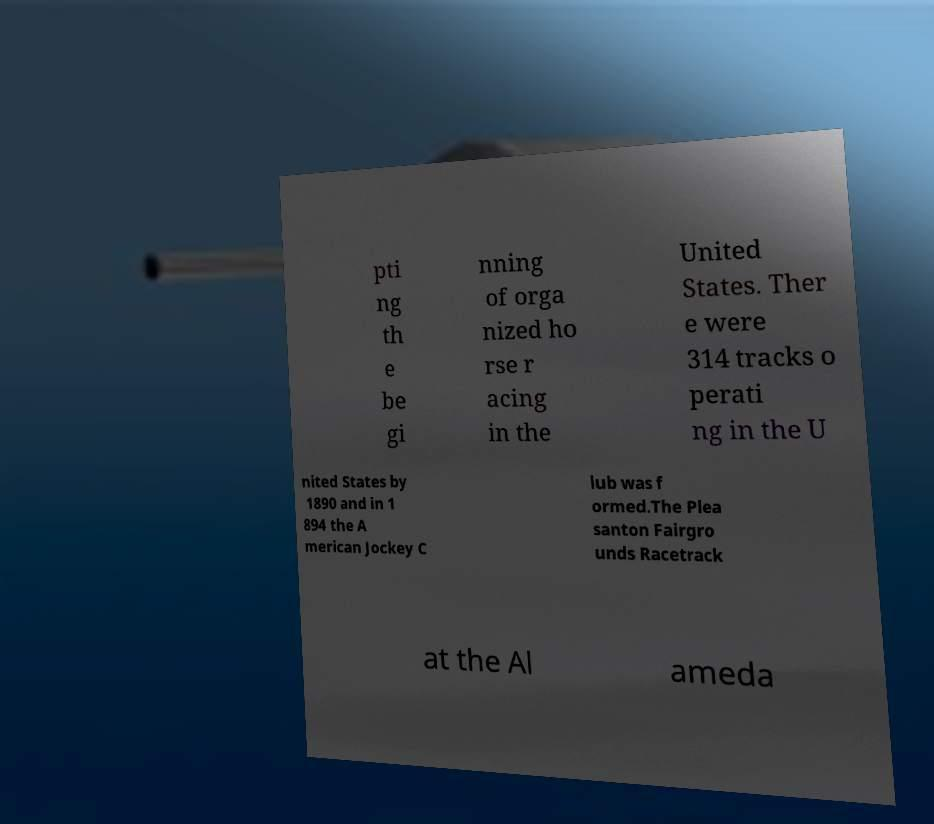Please read and relay the text visible in this image. What does it say? pti ng th e be gi nning of orga nized ho rse r acing in the United States. Ther e were 314 tracks o perati ng in the U nited States by 1890 and in 1 894 the A merican Jockey C lub was f ormed.The Plea santon Fairgro unds Racetrack at the Al ameda 